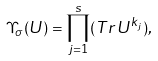Convert formula to latex. <formula><loc_0><loc_0><loc_500><loc_500>\Upsilon _ { \sigma } ( U ) = \prod _ { j = 1 } ^ { s } ( T r \, U ^ { k _ { j } } ) ,</formula> 